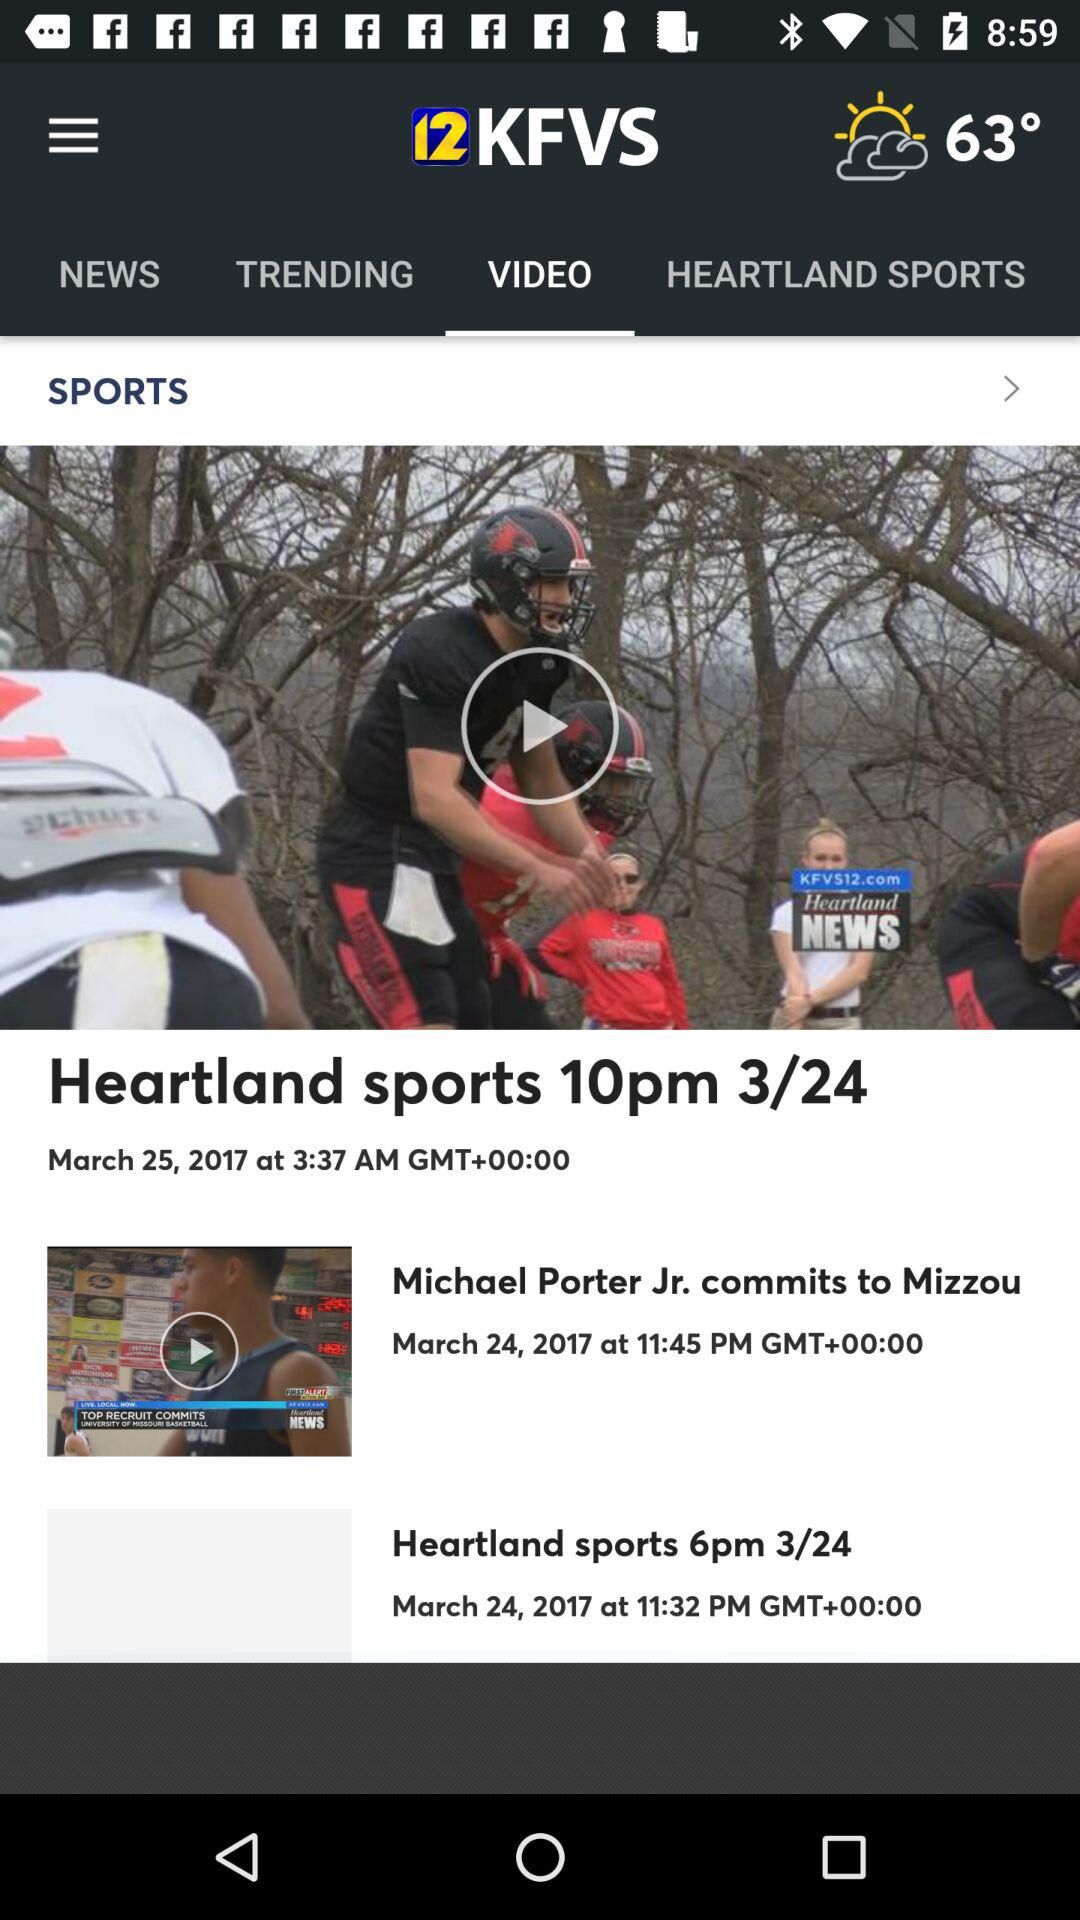What is the title of the video? The titles of the videos are "Heartland sports 10pm 3/24", "Michael Porter Jr. commits to Mizzou" and "Heartland sports 6pm 3/24". 